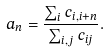<formula> <loc_0><loc_0><loc_500><loc_500>a _ { n } = \frac { \sum _ { i } c _ { i , i + n } } { \sum _ { i , j } c _ { i j } } .</formula> 